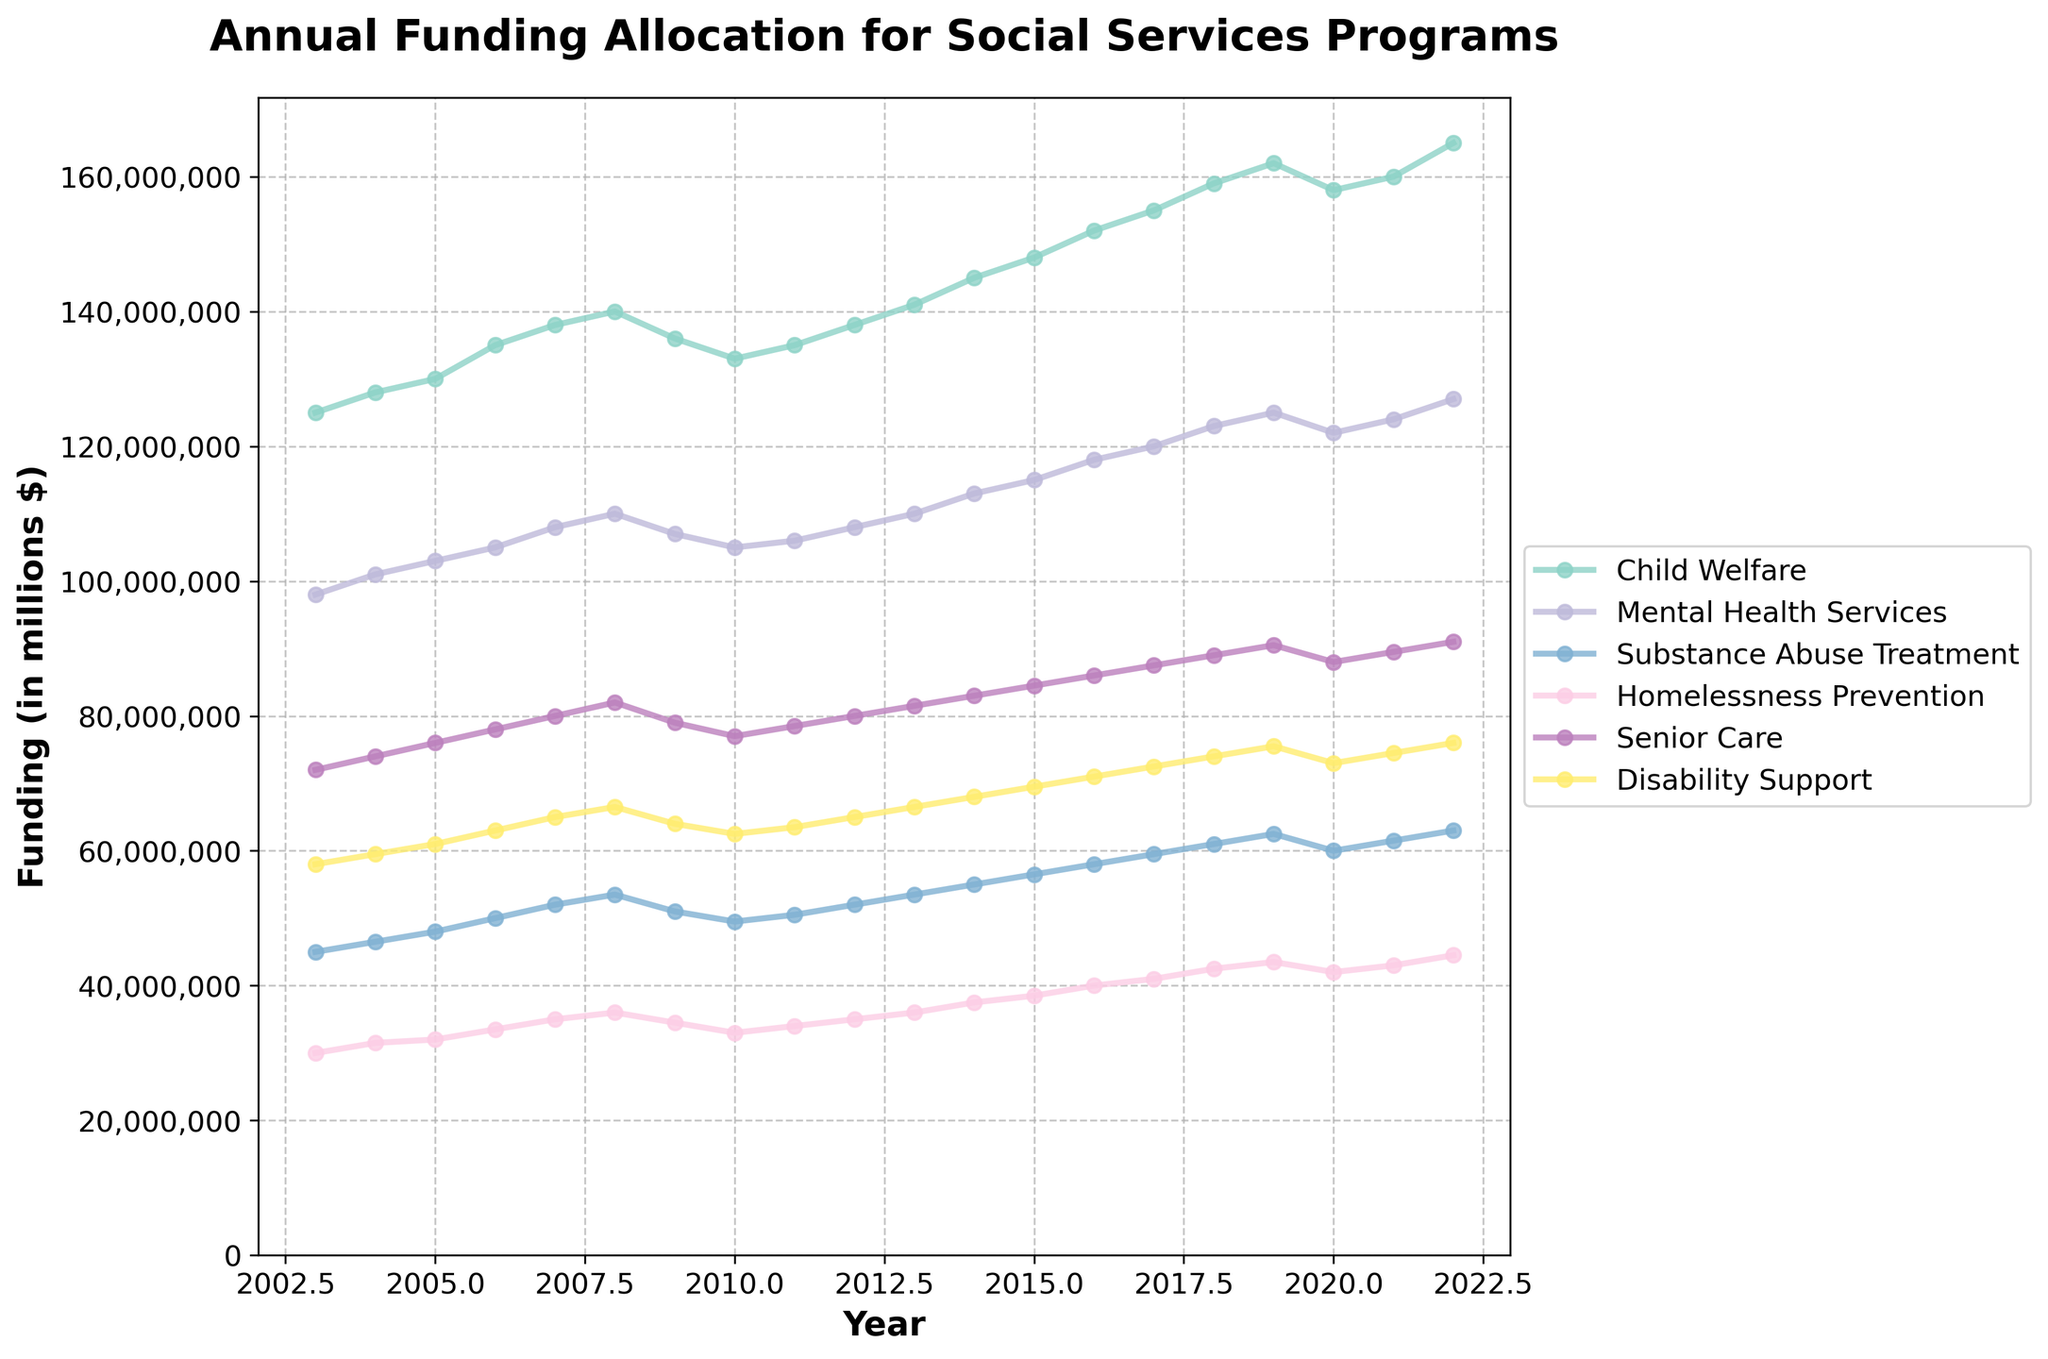What is the average annual funding allocation for Child Welfare over the last 20 years? Calculate the sum of the annual funding allocations for Child Welfare over the 20 years, then divide it by 20: (125+128+130+135+138+140+136+133+135+138+141+145+148+152+155+159+162+158+160+165) / 20 = 2,987 / 20 = 149.35 million dollars
Answer: 149.35 million dollars Between Mental Health Services and Substance Abuse Treatment, which received the highest funding in 2016? Look at the values for both categories in the year 2016: Mental Health Services (118 million dollars) and Substance Abuse Treatment (58 million dollars). Mental Health Services received more funding.
Answer: Mental Health Services What is the total funding allocation for all programs in 2022? Sum the funding amounts for all categories in 2022: 165 + 127 + 63 + 44.5 + 91 + 76 = 566.5 million dollars
Answer: 566.5 million dollars Compare the funding trends for Child Welfare and Disability Support from 2003 to 2022. Which program shows a more significant increase? Initial value of Child Welfare in 2003: 125 million dollars and in 2022: 165 million dollars. Initial value of Disability Support in 2003: 58 million dollars and in 2022: 76 million dollars. Increase for Child Welfare: 40 million dollars, Increase for Disability Support: 18 million dollars. Child Welfare shows a more significant increase.
Answer: Child Welfare What was the funding for Homelessness Prevention in 2010, and how does it compare to the funding in 2012? Funding for Homelessness Prevention in 2010: 33 million dollars, and in 2012: 35 million dollars. The funding increased by 2 million dollars.
Answer: 2 million dollars Which program received the least funding in 2007, and how much was it? Look at the values for all categories in 2007 and find the smallest one: Homelessness Prevention received 35 million dollars.
Answer: Homelessness Prevention, 35 million dollars What is the median funding amount for Senior Care between 2003 and 2022? Arrange the values for Senior Care from lowest to highest and identify the middle value. In this case: 72, 74, 76, 78, 79, 77, 77, 78.5, 83, 86, 89, 91, 83, 85, 87.5 = 2003 to 2022. Median is the average of the 10th and 11th values: (83 + 86) / 2 = 84.5 million dollars.
Answer: 84.5 million dollars Over the 20-year period, in which year did Child Welfare funding see a decrease from the previous year? Identify any declines by comparing values year by year for Child Welfare. The only decrease observed was between 2008 (140 million) and 2009 (136 million).
Answer: 2009 From the given programs, which one had a constant upward trend in funding from 2003 to 2022 without a single year of decline? Assess the funding amounts over the years for each program to identify any declines. Mental Health Services, Senior Care, and Disability Support all show a constant increase without decline.
Answer: Mental Health Services, Senior Care, Disability Support 